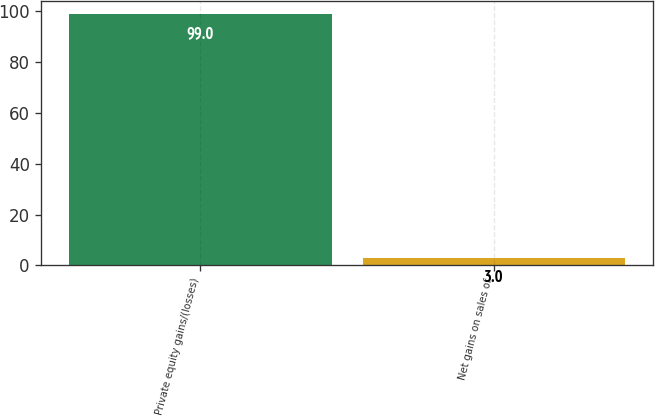<chart> <loc_0><loc_0><loc_500><loc_500><bar_chart><fcel>Private equity gains/(losses)<fcel>Net gains on sales of<nl><fcel>99<fcel>3<nl></chart> 